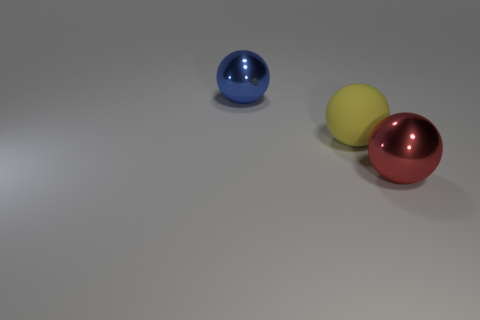Are there any matte things in front of the big metallic ball that is behind the large red thing?
Your answer should be compact. Yes. There is a big matte object that is the same shape as the large blue metallic thing; what is its color?
Your answer should be very brief. Yellow. Do the large metallic object to the right of the big blue object and the matte thing have the same color?
Keep it short and to the point. No. What number of objects are big metallic things that are to the left of the red sphere or balls?
Your answer should be compact. 3. There is a big yellow ball that is left of the metal ball on the right side of the big metal sphere left of the red metallic sphere; what is it made of?
Give a very brief answer. Rubber. Is the number of blue balls in front of the big yellow rubber sphere greater than the number of things that are to the right of the large red metallic sphere?
Ensure brevity in your answer.  No. What number of balls are either big metal things or yellow matte things?
Provide a short and direct response. 3. How many blue metal objects are to the left of the big metal object that is in front of the large thing behind the yellow matte ball?
Offer a very short reply. 1. Are there more yellow matte balls than big objects?
Ensure brevity in your answer.  No. Is the blue ball the same size as the red metallic object?
Keep it short and to the point. Yes. 